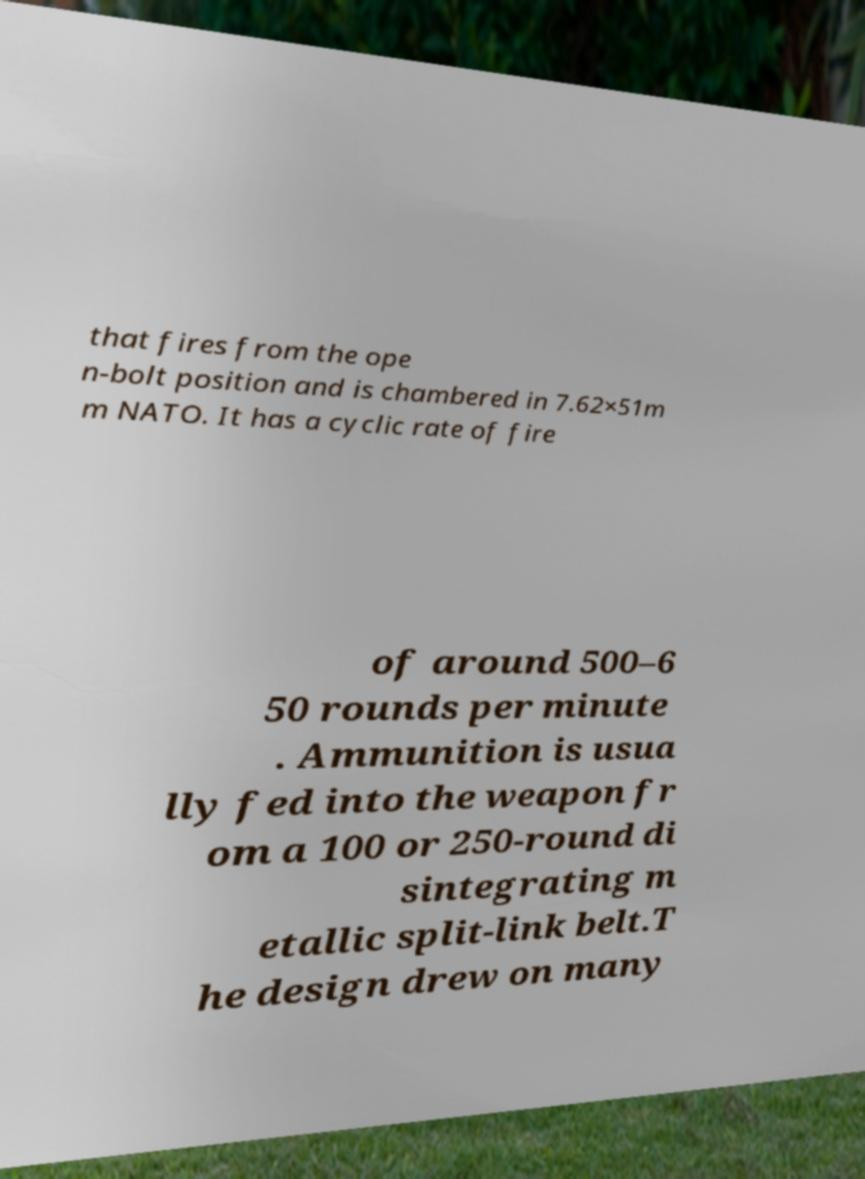Please read and relay the text visible in this image. What does it say? that fires from the ope n-bolt position and is chambered in 7.62×51m m NATO. It has a cyclic rate of fire of around 500–6 50 rounds per minute . Ammunition is usua lly fed into the weapon fr om a 100 or 250-round di sintegrating m etallic split-link belt.T he design drew on many 